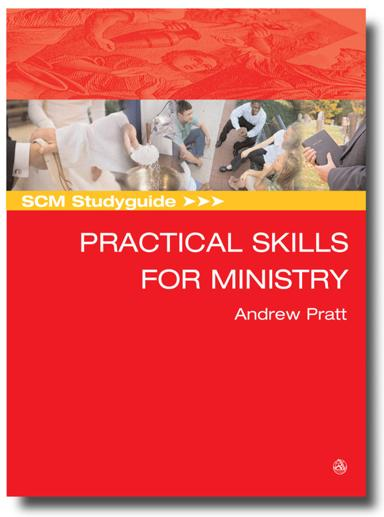What are the implications of using a red color scheme for this ministry guide's cover? Red often symbolizes passion, importance, and urgency, which could suggest the critical and heartfelt nature of acquiring practical ministry skills. It makes the guide stand out and emphasizes the energy and dedication required in ministry work. 